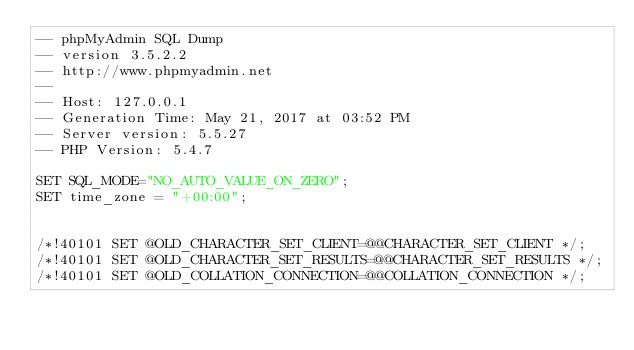<code> <loc_0><loc_0><loc_500><loc_500><_SQL_>-- phpMyAdmin SQL Dump
-- version 3.5.2.2
-- http://www.phpmyadmin.net
--
-- Host: 127.0.0.1
-- Generation Time: May 21, 2017 at 03:52 PM
-- Server version: 5.5.27
-- PHP Version: 5.4.7

SET SQL_MODE="NO_AUTO_VALUE_ON_ZERO";
SET time_zone = "+00:00";


/*!40101 SET @OLD_CHARACTER_SET_CLIENT=@@CHARACTER_SET_CLIENT */;
/*!40101 SET @OLD_CHARACTER_SET_RESULTS=@@CHARACTER_SET_RESULTS */;
/*!40101 SET @OLD_COLLATION_CONNECTION=@@COLLATION_CONNECTION */;</code> 